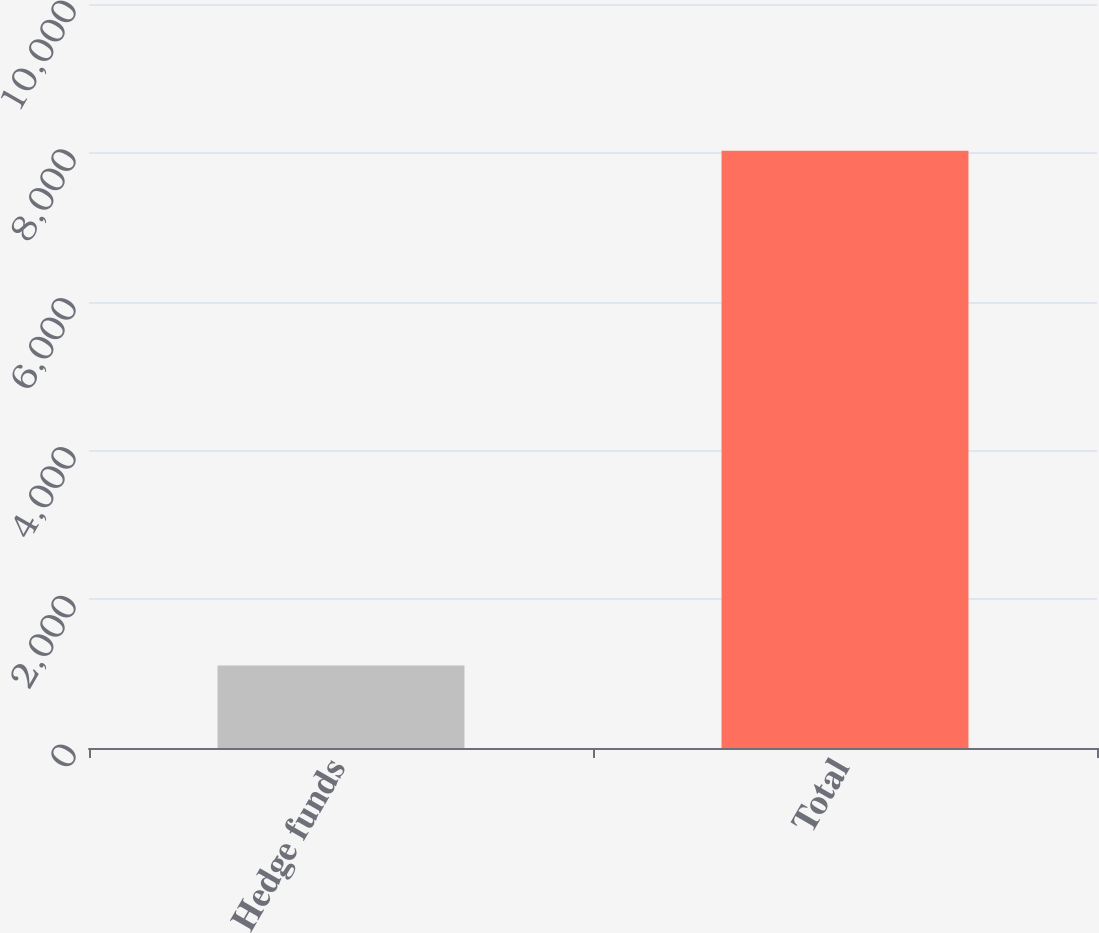Convert chart. <chart><loc_0><loc_0><loc_500><loc_500><bar_chart><fcel>Hedge funds<fcel>Total<nl><fcel>1109<fcel>8026<nl></chart> 